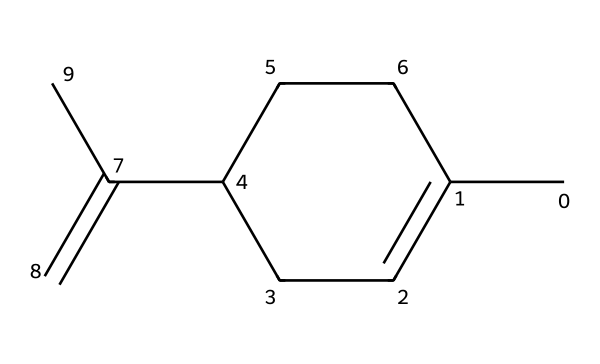What is the molecular formula of limonene? The SMILES representation can be converted to give the molecular formula by counting the number of each type of atom present. For limonene, there are ten carbon atoms, sixteen hydrogen atoms, and no other elements, leading to the formula C10H16.
Answer: C10H16 How many chiral centers are present in limonene? A chiral center is defined as a carbon atom that is bonded to four different groups. By analyzing the SMILES structure, we find one carbon atom behaves as a chiral center, indicating there is one.
Answer: 1 What type of geometric isomerism does limonene exhibit? Limonene has a double bond in its structure that can create cis/trans isomerism depending on the orientation of the substituents around that bond. The presence of this double bond indicates that limonene exhibits geometric isomerism.
Answer: geometric isomerism How many double bonds are present in limonene? By examining the structure encoded in the SMILES representation, it can be seen that there is one double bond present in the molecule, specifically between the carbons in the alkene portion.
Answer: 1 What are the primary functional groups in limonene? The structure is primarily hydrocarbon with double bonds but does not show other functional groups like alcohols or carboxylic acids explicitly. Therefore, limonene is categorized mainly as an alkene without additional functional groups.
Answer: alkene What type of compound is limonene classified as? The structure shows that limonene is an organic compound composed only of carbon and hydrogen, classified specifically as a monoterpene. This classification is derived from its structure and properties as part of the terpene family.
Answer: monoterpene What type of chirality does limonene possess? Limonene demonstrates optical activity due to the presence of its single chiral center, which leads to its existence as enantiomers (D-limonene and L-limonene), thus possessing stereoisomerism.
Answer: stereoisomerism 